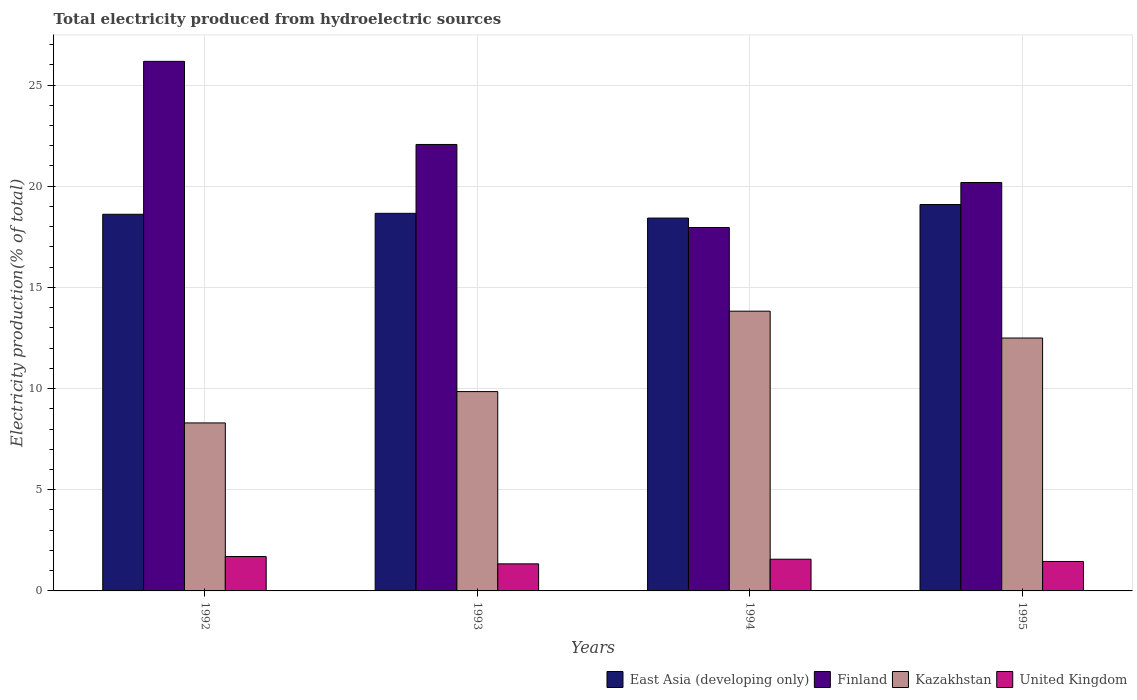How many different coloured bars are there?
Make the answer very short. 4. Are the number of bars per tick equal to the number of legend labels?
Provide a succinct answer. Yes. How many bars are there on the 3rd tick from the left?
Provide a short and direct response. 4. What is the total electricity produced in United Kingdom in 1994?
Your answer should be very brief. 1.57. Across all years, what is the maximum total electricity produced in United Kingdom?
Provide a short and direct response. 1.7. Across all years, what is the minimum total electricity produced in United Kingdom?
Make the answer very short. 1.34. In which year was the total electricity produced in Finland maximum?
Offer a very short reply. 1992. What is the total total electricity produced in East Asia (developing only) in the graph?
Your response must be concise. 74.79. What is the difference between the total electricity produced in East Asia (developing only) in 1992 and that in 1993?
Offer a terse response. -0.05. What is the difference between the total electricity produced in Kazakhstan in 1993 and the total electricity produced in East Asia (developing only) in 1995?
Make the answer very short. -9.24. What is the average total electricity produced in Kazakhstan per year?
Offer a terse response. 11.12. In the year 1994, what is the difference between the total electricity produced in United Kingdom and total electricity produced in Finland?
Provide a succinct answer. -16.39. What is the ratio of the total electricity produced in Kazakhstan in 1992 to that in 1993?
Provide a succinct answer. 0.84. What is the difference between the highest and the second highest total electricity produced in United Kingdom?
Give a very brief answer. 0.13. What is the difference between the highest and the lowest total electricity produced in United Kingdom?
Your answer should be compact. 0.36. In how many years, is the total electricity produced in Finland greater than the average total electricity produced in Finland taken over all years?
Give a very brief answer. 2. Is the sum of the total electricity produced in Finland in 1992 and 1995 greater than the maximum total electricity produced in United Kingdom across all years?
Your answer should be very brief. Yes. Is it the case that in every year, the sum of the total electricity produced in United Kingdom and total electricity produced in Finland is greater than the sum of total electricity produced in East Asia (developing only) and total electricity produced in Kazakhstan?
Provide a short and direct response. No. What does the 2nd bar from the left in 1993 represents?
Provide a short and direct response. Finland. What does the 4th bar from the right in 1995 represents?
Give a very brief answer. East Asia (developing only). Is it the case that in every year, the sum of the total electricity produced in United Kingdom and total electricity produced in Finland is greater than the total electricity produced in Kazakhstan?
Your response must be concise. Yes. Are all the bars in the graph horizontal?
Offer a very short reply. No. What is the difference between two consecutive major ticks on the Y-axis?
Your answer should be compact. 5. Are the values on the major ticks of Y-axis written in scientific E-notation?
Offer a terse response. No. Does the graph contain any zero values?
Provide a short and direct response. No. Does the graph contain grids?
Give a very brief answer. Yes. How are the legend labels stacked?
Provide a short and direct response. Horizontal. What is the title of the graph?
Your answer should be compact. Total electricity produced from hydroelectric sources. What is the label or title of the X-axis?
Provide a short and direct response. Years. What is the Electricity production(% of total) in East Asia (developing only) in 1992?
Make the answer very short. 18.61. What is the Electricity production(% of total) of Finland in 1992?
Your response must be concise. 26.17. What is the Electricity production(% of total) of Kazakhstan in 1992?
Give a very brief answer. 8.3. What is the Electricity production(% of total) of United Kingdom in 1992?
Make the answer very short. 1.7. What is the Electricity production(% of total) of East Asia (developing only) in 1993?
Your answer should be very brief. 18.66. What is the Electricity production(% of total) of Finland in 1993?
Your answer should be very brief. 22.06. What is the Electricity production(% of total) in Kazakhstan in 1993?
Give a very brief answer. 9.85. What is the Electricity production(% of total) in United Kingdom in 1993?
Your response must be concise. 1.34. What is the Electricity production(% of total) in East Asia (developing only) in 1994?
Your response must be concise. 18.43. What is the Electricity production(% of total) of Finland in 1994?
Keep it short and to the point. 17.96. What is the Electricity production(% of total) in Kazakhstan in 1994?
Provide a short and direct response. 13.82. What is the Electricity production(% of total) of United Kingdom in 1994?
Your answer should be compact. 1.57. What is the Electricity production(% of total) in East Asia (developing only) in 1995?
Provide a short and direct response. 19.09. What is the Electricity production(% of total) in Finland in 1995?
Give a very brief answer. 20.18. What is the Electricity production(% of total) of Kazakhstan in 1995?
Offer a very short reply. 12.5. What is the Electricity production(% of total) in United Kingdom in 1995?
Provide a succinct answer. 1.46. Across all years, what is the maximum Electricity production(% of total) of East Asia (developing only)?
Keep it short and to the point. 19.09. Across all years, what is the maximum Electricity production(% of total) of Finland?
Offer a terse response. 26.17. Across all years, what is the maximum Electricity production(% of total) of Kazakhstan?
Ensure brevity in your answer.  13.82. Across all years, what is the maximum Electricity production(% of total) in United Kingdom?
Ensure brevity in your answer.  1.7. Across all years, what is the minimum Electricity production(% of total) in East Asia (developing only)?
Your answer should be very brief. 18.43. Across all years, what is the minimum Electricity production(% of total) of Finland?
Your answer should be compact. 17.96. Across all years, what is the minimum Electricity production(% of total) in Kazakhstan?
Provide a short and direct response. 8.3. Across all years, what is the minimum Electricity production(% of total) of United Kingdom?
Make the answer very short. 1.34. What is the total Electricity production(% of total) in East Asia (developing only) in the graph?
Ensure brevity in your answer.  74.79. What is the total Electricity production(% of total) in Finland in the graph?
Your answer should be compact. 86.38. What is the total Electricity production(% of total) of Kazakhstan in the graph?
Your answer should be very brief. 44.48. What is the total Electricity production(% of total) in United Kingdom in the graph?
Your answer should be very brief. 6.06. What is the difference between the Electricity production(% of total) of East Asia (developing only) in 1992 and that in 1993?
Give a very brief answer. -0.05. What is the difference between the Electricity production(% of total) in Finland in 1992 and that in 1993?
Provide a succinct answer. 4.11. What is the difference between the Electricity production(% of total) of Kazakhstan in 1992 and that in 1993?
Ensure brevity in your answer.  -1.55. What is the difference between the Electricity production(% of total) of United Kingdom in 1992 and that in 1993?
Keep it short and to the point. 0.36. What is the difference between the Electricity production(% of total) in East Asia (developing only) in 1992 and that in 1994?
Provide a succinct answer. 0.19. What is the difference between the Electricity production(% of total) of Finland in 1992 and that in 1994?
Offer a very short reply. 8.21. What is the difference between the Electricity production(% of total) of Kazakhstan in 1992 and that in 1994?
Keep it short and to the point. -5.52. What is the difference between the Electricity production(% of total) in United Kingdom in 1992 and that in 1994?
Give a very brief answer. 0.13. What is the difference between the Electricity production(% of total) in East Asia (developing only) in 1992 and that in 1995?
Ensure brevity in your answer.  -0.48. What is the difference between the Electricity production(% of total) in Finland in 1992 and that in 1995?
Give a very brief answer. 5.99. What is the difference between the Electricity production(% of total) of Kazakhstan in 1992 and that in 1995?
Your answer should be compact. -4.2. What is the difference between the Electricity production(% of total) in United Kingdom in 1992 and that in 1995?
Your answer should be compact. 0.25. What is the difference between the Electricity production(% of total) in East Asia (developing only) in 1993 and that in 1994?
Your response must be concise. 0.23. What is the difference between the Electricity production(% of total) of Finland in 1993 and that in 1994?
Your answer should be compact. 4.1. What is the difference between the Electricity production(% of total) of Kazakhstan in 1993 and that in 1994?
Offer a terse response. -3.97. What is the difference between the Electricity production(% of total) in United Kingdom in 1993 and that in 1994?
Your answer should be compact. -0.23. What is the difference between the Electricity production(% of total) of East Asia (developing only) in 1993 and that in 1995?
Ensure brevity in your answer.  -0.43. What is the difference between the Electricity production(% of total) of Finland in 1993 and that in 1995?
Make the answer very short. 1.88. What is the difference between the Electricity production(% of total) in Kazakhstan in 1993 and that in 1995?
Give a very brief answer. -2.65. What is the difference between the Electricity production(% of total) of United Kingdom in 1993 and that in 1995?
Your answer should be compact. -0.12. What is the difference between the Electricity production(% of total) in East Asia (developing only) in 1994 and that in 1995?
Your answer should be very brief. -0.67. What is the difference between the Electricity production(% of total) of Finland in 1994 and that in 1995?
Make the answer very short. -2.22. What is the difference between the Electricity production(% of total) in Kazakhstan in 1994 and that in 1995?
Your answer should be very brief. 1.33. What is the difference between the Electricity production(% of total) in United Kingdom in 1994 and that in 1995?
Your answer should be very brief. 0.11. What is the difference between the Electricity production(% of total) in East Asia (developing only) in 1992 and the Electricity production(% of total) in Finland in 1993?
Give a very brief answer. -3.45. What is the difference between the Electricity production(% of total) of East Asia (developing only) in 1992 and the Electricity production(% of total) of Kazakhstan in 1993?
Offer a very short reply. 8.76. What is the difference between the Electricity production(% of total) in East Asia (developing only) in 1992 and the Electricity production(% of total) in United Kingdom in 1993?
Ensure brevity in your answer.  17.28. What is the difference between the Electricity production(% of total) in Finland in 1992 and the Electricity production(% of total) in Kazakhstan in 1993?
Your answer should be compact. 16.32. What is the difference between the Electricity production(% of total) of Finland in 1992 and the Electricity production(% of total) of United Kingdom in 1993?
Offer a terse response. 24.83. What is the difference between the Electricity production(% of total) in Kazakhstan in 1992 and the Electricity production(% of total) in United Kingdom in 1993?
Your response must be concise. 6.96. What is the difference between the Electricity production(% of total) of East Asia (developing only) in 1992 and the Electricity production(% of total) of Finland in 1994?
Provide a succinct answer. 0.65. What is the difference between the Electricity production(% of total) of East Asia (developing only) in 1992 and the Electricity production(% of total) of Kazakhstan in 1994?
Your answer should be very brief. 4.79. What is the difference between the Electricity production(% of total) of East Asia (developing only) in 1992 and the Electricity production(% of total) of United Kingdom in 1994?
Ensure brevity in your answer.  17.05. What is the difference between the Electricity production(% of total) of Finland in 1992 and the Electricity production(% of total) of Kazakhstan in 1994?
Keep it short and to the point. 12.35. What is the difference between the Electricity production(% of total) in Finland in 1992 and the Electricity production(% of total) in United Kingdom in 1994?
Provide a short and direct response. 24.6. What is the difference between the Electricity production(% of total) in Kazakhstan in 1992 and the Electricity production(% of total) in United Kingdom in 1994?
Ensure brevity in your answer.  6.73. What is the difference between the Electricity production(% of total) of East Asia (developing only) in 1992 and the Electricity production(% of total) of Finland in 1995?
Ensure brevity in your answer.  -1.57. What is the difference between the Electricity production(% of total) of East Asia (developing only) in 1992 and the Electricity production(% of total) of Kazakhstan in 1995?
Offer a terse response. 6.12. What is the difference between the Electricity production(% of total) of East Asia (developing only) in 1992 and the Electricity production(% of total) of United Kingdom in 1995?
Your response must be concise. 17.16. What is the difference between the Electricity production(% of total) in Finland in 1992 and the Electricity production(% of total) in Kazakhstan in 1995?
Make the answer very short. 13.67. What is the difference between the Electricity production(% of total) of Finland in 1992 and the Electricity production(% of total) of United Kingdom in 1995?
Provide a short and direct response. 24.72. What is the difference between the Electricity production(% of total) in Kazakhstan in 1992 and the Electricity production(% of total) in United Kingdom in 1995?
Your answer should be compact. 6.85. What is the difference between the Electricity production(% of total) of East Asia (developing only) in 1993 and the Electricity production(% of total) of Finland in 1994?
Ensure brevity in your answer.  0.7. What is the difference between the Electricity production(% of total) of East Asia (developing only) in 1993 and the Electricity production(% of total) of Kazakhstan in 1994?
Offer a very short reply. 4.84. What is the difference between the Electricity production(% of total) of East Asia (developing only) in 1993 and the Electricity production(% of total) of United Kingdom in 1994?
Provide a short and direct response. 17.09. What is the difference between the Electricity production(% of total) in Finland in 1993 and the Electricity production(% of total) in Kazakhstan in 1994?
Ensure brevity in your answer.  8.24. What is the difference between the Electricity production(% of total) of Finland in 1993 and the Electricity production(% of total) of United Kingdom in 1994?
Provide a succinct answer. 20.5. What is the difference between the Electricity production(% of total) in Kazakhstan in 1993 and the Electricity production(% of total) in United Kingdom in 1994?
Your response must be concise. 8.28. What is the difference between the Electricity production(% of total) of East Asia (developing only) in 1993 and the Electricity production(% of total) of Finland in 1995?
Your answer should be very brief. -1.52. What is the difference between the Electricity production(% of total) in East Asia (developing only) in 1993 and the Electricity production(% of total) in Kazakhstan in 1995?
Provide a succinct answer. 6.16. What is the difference between the Electricity production(% of total) of East Asia (developing only) in 1993 and the Electricity production(% of total) of United Kingdom in 1995?
Your answer should be compact. 17.2. What is the difference between the Electricity production(% of total) of Finland in 1993 and the Electricity production(% of total) of Kazakhstan in 1995?
Ensure brevity in your answer.  9.57. What is the difference between the Electricity production(% of total) in Finland in 1993 and the Electricity production(% of total) in United Kingdom in 1995?
Give a very brief answer. 20.61. What is the difference between the Electricity production(% of total) of Kazakhstan in 1993 and the Electricity production(% of total) of United Kingdom in 1995?
Keep it short and to the point. 8.4. What is the difference between the Electricity production(% of total) in East Asia (developing only) in 1994 and the Electricity production(% of total) in Finland in 1995?
Make the answer very short. -1.76. What is the difference between the Electricity production(% of total) in East Asia (developing only) in 1994 and the Electricity production(% of total) in Kazakhstan in 1995?
Make the answer very short. 5.93. What is the difference between the Electricity production(% of total) in East Asia (developing only) in 1994 and the Electricity production(% of total) in United Kingdom in 1995?
Your answer should be compact. 16.97. What is the difference between the Electricity production(% of total) of Finland in 1994 and the Electricity production(% of total) of Kazakhstan in 1995?
Provide a succinct answer. 5.46. What is the difference between the Electricity production(% of total) of Finland in 1994 and the Electricity production(% of total) of United Kingdom in 1995?
Ensure brevity in your answer.  16.5. What is the difference between the Electricity production(% of total) of Kazakhstan in 1994 and the Electricity production(% of total) of United Kingdom in 1995?
Your answer should be compact. 12.37. What is the average Electricity production(% of total) in East Asia (developing only) per year?
Your response must be concise. 18.7. What is the average Electricity production(% of total) of Finland per year?
Offer a terse response. 21.59. What is the average Electricity production(% of total) of Kazakhstan per year?
Ensure brevity in your answer.  11.12. What is the average Electricity production(% of total) in United Kingdom per year?
Your answer should be very brief. 1.52. In the year 1992, what is the difference between the Electricity production(% of total) in East Asia (developing only) and Electricity production(% of total) in Finland?
Offer a terse response. -7.56. In the year 1992, what is the difference between the Electricity production(% of total) in East Asia (developing only) and Electricity production(% of total) in Kazakhstan?
Provide a short and direct response. 10.31. In the year 1992, what is the difference between the Electricity production(% of total) in East Asia (developing only) and Electricity production(% of total) in United Kingdom?
Provide a succinct answer. 16.91. In the year 1992, what is the difference between the Electricity production(% of total) in Finland and Electricity production(% of total) in Kazakhstan?
Make the answer very short. 17.87. In the year 1992, what is the difference between the Electricity production(% of total) in Finland and Electricity production(% of total) in United Kingdom?
Your answer should be very brief. 24.47. In the year 1992, what is the difference between the Electricity production(% of total) in Kazakhstan and Electricity production(% of total) in United Kingdom?
Ensure brevity in your answer.  6.6. In the year 1993, what is the difference between the Electricity production(% of total) of East Asia (developing only) and Electricity production(% of total) of Finland?
Offer a very short reply. -3.4. In the year 1993, what is the difference between the Electricity production(% of total) in East Asia (developing only) and Electricity production(% of total) in Kazakhstan?
Offer a terse response. 8.81. In the year 1993, what is the difference between the Electricity production(% of total) of East Asia (developing only) and Electricity production(% of total) of United Kingdom?
Your answer should be very brief. 17.32. In the year 1993, what is the difference between the Electricity production(% of total) of Finland and Electricity production(% of total) of Kazakhstan?
Make the answer very short. 12.21. In the year 1993, what is the difference between the Electricity production(% of total) in Finland and Electricity production(% of total) in United Kingdom?
Offer a very short reply. 20.73. In the year 1993, what is the difference between the Electricity production(% of total) of Kazakhstan and Electricity production(% of total) of United Kingdom?
Your response must be concise. 8.51. In the year 1994, what is the difference between the Electricity production(% of total) of East Asia (developing only) and Electricity production(% of total) of Finland?
Provide a short and direct response. 0.47. In the year 1994, what is the difference between the Electricity production(% of total) of East Asia (developing only) and Electricity production(% of total) of Kazakhstan?
Your response must be concise. 4.6. In the year 1994, what is the difference between the Electricity production(% of total) of East Asia (developing only) and Electricity production(% of total) of United Kingdom?
Offer a terse response. 16.86. In the year 1994, what is the difference between the Electricity production(% of total) in Finland and Electricity production(% of total) in Kazakhstan?
Give a very brief answer. 4.14. In the year 1994, what is the difference between the Electricity production(% of total) in Finland and Electricity production(% of total) in United Kingdom?
Make the answer very short. 16.39. In the year 1994, what is the difference between the Electricity production(% of total) in Kazakhstan and Electricity production(% of total) in United Kingdom?
Your response must be concise. 12.26. In the year 1995, what is the difference between the Electricity production(% of total) in East Asia (developing only) and Electricity production(% of total) in Finland?
Make the answer very short. -1.09. In the year 1995, what is the difference between the Electricity production(% of total) in East Asia (developing only) and Electricity production(% of total) in Kazakhstan?
Offer a terse response. 6.6. In the year 1995, what is the difference between the Electricity production(% of total) of East Asia (developing only) and Electricity production(% of total) of United Kingdom?
Your response must be concise. 17.64. In the year 1995, what is the difference between the Electricity production(% of total) in Finland and Electricity production(% of total) in Kazakhstan?
Your answer should be very brief. 7.69. In the year 1995, what is the difference between the Electricity production(% of total) of Finland and Electricity production(% of total) of United Kingdom?
Offer a terse response. 18.73. In the year 1995, what is the difference between the Electricity production(% of total) in Kazakhstan and Electricity production(% of total) in United Kingdom?
Offer a terse response. 11.04. What is the ratio of the Electricity production(% of total) in Finland in 1992 to that in 1993?
Your answer should be compact. 1.19. What is the ratio of the Electricity production(% of total) of Kazakhstan in 1992 to that in 1993?
Provide a succinct answer. 0.84. What is the ratio of the Electricity production(% of total) in United Kingdom in 1992 to that in 1993?
Offer a terse response. 1.27. What is the ratio of the Electricity production(% of total) of East Asia (developing only) in 1992 to that in 1994?
Ensure brevity in your answer.  1.01. What is the ratio of the Electricity production(% of total) of Finland in 1992 to that in 1994?
Provide a succinct answer. 1.46. What is the ratio of the Electricity production(% of total) of Kazakhstan in 1992 to that in 1994?
Your response must be concise. 0.6. What is the ratio of the Electricity production(% of total) of United Kingdom in 1992 to that in 1994?
Provide a short and direct response. 1.09. What is the ratio of the Electricity production(% of total) of East Asia (developing only) in 1992 to that in 1995?
Keep it short and to the point. 0.97. What is the ratio of the Electricity production(% of total) of Finland in 1992 to that in 1995?
Ensure brevity in your answer.  1.3. What is the ratio of the Electricity production(% of total) of Kazakhstan in 1992 to that in 1995?
Your response must be concise. 0.66. What is the ratio of the Electricity production(% of total) in United Kingdom in 1992 to that in 1995?
Your answer should be very brief. 1.17. What is the ratio of the Electricity production(% of total) of East Asia (developing only) in 1993 to that in 1994?
Offer a very short reply. 1.01. What is the ratio of the Electricity production(% of total) in Finland in 1993 to that in 1994?
Your answer should be compact. 1.23. What is the ratio of the Electricity production(% of total) of Kazakhstan in 1993 to that in 1994?
Keep it short and to the point. 0.71. What is the ratio of the Electricity production(% of total) in United Kingdom in 1993 to that in 1994?
Ensure brevity in your answer.  0.85. What is the ratio of the Electricity production(% of total) in East Asia (developing only) in 1993 to that in 1995?
Keep it short and to the point. 0.98. What is the ratio of the Electricity production(% of total) in Finland in 1993 to that in 1995?
Provide a short and direct response. 1.09. What is the ratio of the Electricity production(% of total) in Kazakhstan in 1993 to that in 1995?
Your answer should be compact. 0.79. What is the ratio of the Electricity production(% of total) of United Kingdom in 1993 to that in 1995?
Ensure brevity in your answer.  0.92. What is the ratio of the Electricity production(% of total) of East Asia (developing only) in 1994 to that in 1995?
Your answer should be compact. 0.96. What is the ratio of the Electricity production(% of total) in Finland in 1994 to that in 1995?
Ensure brevity in your answer.  0.89. What is the ratio of the Electricity production(% of total) in Kazakhstan in 1994 to that in 1995?
Keep it short and to the point. 1.11. What is the ratio of the Electricity production(% of total) in United Kingdom in 1994 to that in 1995?
Offer a very short reply. 1.08. What is the difference between the highest and the second highest Electricity production(% of total) of East Asia (developing only)?
Offer a very short reply. 0.43. What is the difference between the highest and the second highest Electricity production(% of total) in Finland?
Your answer should be very brief. 4.11. What is the difference between the highest and the second highest Electricity production(% of total) in Kazakhstan?
Ensure brevity in your answer.  1.33. What is the difference between the highest and the second highest Electricity production(% of total) in United Kingdom?
Your response must be concise. 0.13. What is the difference between the highest and the lowest Electricity production(% of total) of East Asia (developing only)?
Offer a terse response. 0.67. What is the difference between the highest and the lowest Electricity production(% of total) of Finland?
Keep it short and to the point. 8.21. What is the difference between the highest and the lowest Electricity production(% of total) in Kazakhstan?
Provide a succinct answer. 5.52. What is the difference between the highest and the lowest Electricity production(% of total) of United Kingdom?
Offer a terse response. 0.36. 